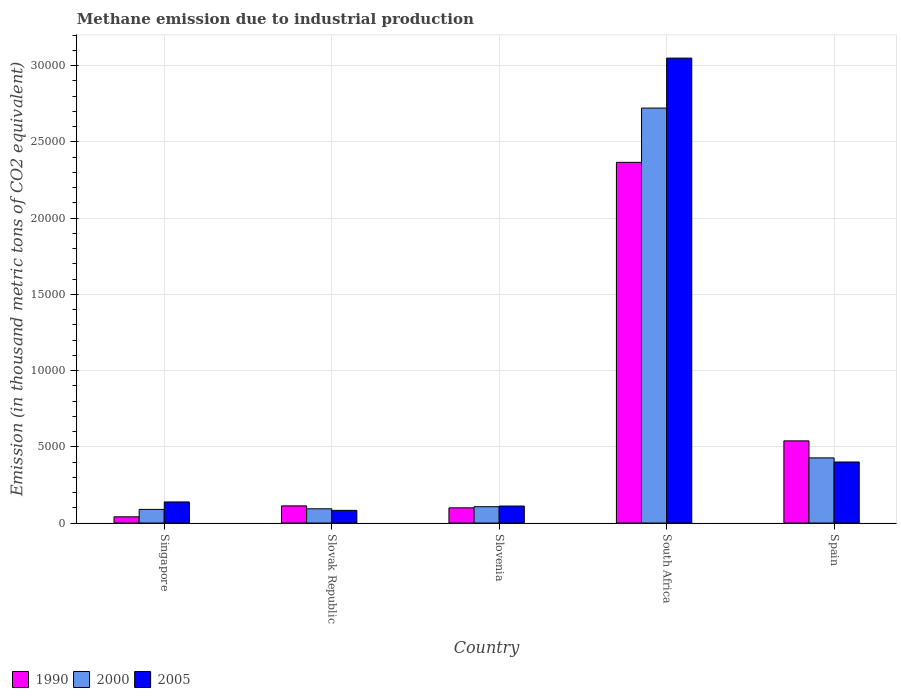How many different coloured bars are there?
Give a very brief answer. 3. How many groups of bars are there?
Offer a terse response. 5. How many bars are there on the 3rd tick from the left?
Provide a succinct answer. 3. How many bars are there on the 1st tick from the right?
Ensure brevity in your answer.  3. In how many cases, is the number of bars for a given country not equal to the number of legend labels?
Your answer should be very brief. 0. What is the amount of methane emitted in 2000 in Slovenia?
Provide a short and direct response. 1071.1. Across all countries, what is the maximum amount of methane emitted in 2005?
Offer a very short reply. 3.05e+04. Across all countries, what is the minimum amount of methane emitted in 2000?
Ensure brevity in your answer.  893.5. In which country was the amount of methane emitted in 1990 maximum?
Keep it short and to the point. South Africa. In which country was the amount of methane emitted in 2005 minimum?
Offer a very short reply. Slovak Republic. What is the total amount of methane emitted in 2005 in the graph?
Provide a short and direct response. 3.78e+04. What is the difference between the amount of methane emitted in 2000 in Slovak Republic and that in Slovenia?
Your answer should be compact. -137. What is the difference between the amount of methane emitted in 2000 in Slovenia and the amount of methane emitted in 2005 in Spain?
Provide a short and direct response. -2931.5. What is the average amount of methane emitted in 2005 per country?
Your answer should be compact. 7563.04. What is the difference between the amount of methane emitted of/in 2005 and amount of methane emitted of/in 2000 in Slovenia?
Your response must be concise. 43.3. What is the ratio of the amount of methane emitted in 2000 in Slovak Republic to that in Spain?
Offer a very short reply. 0.22. What is the difference between the highest and the second highest amount of methane emitted in 2000?
Offer a very short reply. 3199.9. What is the difference between the highest and the lowest amount of methane emitted in 2005?
Your response must be concise. 2.97e+04. What does the 1st bar from the left in Singapore represents?
Your response must be concise. 1990. Is it the case that in every country, the sum of the amount of methane emitted in 2005 and amount of methane emitted in 2000 is greater than the amount of methane emitted in 1990?
Provide a short and direct response. Yes. How many bars are there?
Provide a succinct answer. 15. How many countries are there in the graph?
Give a very brief answer. 5. Are the values on the major ticks of Y-axis written in scientific E-notation?
Offer a terse response. No. Does the graph contain grids?
Offer a very short reply. Yes. Where does the legend appear in the graph?
Your answer should be compact. Bottom left. How many legend labels are there?
Your answer should be compact. 3. How are the legend labels stacked?
Your answer should be very brief. Horizontal. What is the title of the graph?
Provide a short and direct response. Methane emission due to industrial production. What is the label or title of the X-axis?
Provide a short and direct response. Country. What is the label or title of the Y-axis?
Keep it short and to the point. Emission (in thousand metric tons of CO2 equivalent). What is the Emission (in thousand metric tons of CO2 equivalent) in 1990 in Singapore?
Your answer should be very brief. 406.8. What is the Emission (in thousand metric tons of CO2 equivalent) in 2000 in Singapore?
Provide a short and direct response. 893.5. What is the Emission (in thousand metric tons of CO2 equivalent) of 2005 in Singapore?
Ensure brevity in your answer.  1383. What is the Emission (in thousand metric tons of CO2 equivalent) in 1990 in Slovak Republic?
Offer a terse response. 1125.1. What is the Emission (in thousand metric tons of CO2 equivalent) in 2000 in Slovak Republic?
Make the answer very short. 934.1. What is the Emission (in thousand metric tons of CO2 equivalent) of 2005 in Slovak Republic?
Your answer should be compact. 830.9. What is the Emission (in thousand metric tons of CO2 equivalent) of 1990 in Slovenia?
Give a very brief answer. 996.3. What is the Emission (in thousand metric tons of CO2 equivalent) in 2000 in Slovenia?
Make the answer very short. 1071.1. What is the Emission (in thousand metric tons of CO2 equivalent) of 2005 in Slovenia?
Provide a short and direct response. 1114.4. What is the Emission (in thousand metric tons of CO2 equivalent) in 1990 in South Africa?
Ensure brevity in your answer.  2.36e+04. What is the Emission (in thousand metric tons of CO2 equivalent) of 2000 in South Africa?
Make the answer very short. 2.72e+04. What is the Emission (in thousand metric tons of CO2 equivalent) in 2005 in South Africa?
Offer a terse response. 3.05e+04. What is the Emission (in thousand metric tons of CO2 equivalent) in 1990 in Spain?
Your answer should be compact. 5387.8. What is the Emission (in thousand metric tons of CO2 equivalent) of 2000 in Spain?
Ensure brevity in your answer.  4271. What is the Emission (in thousand metric tons of CO2 equivalent) in 2005 in Spain?
Keep it short and to the point. 4002.6. Across all countries, what is the maximum Emission (in thousand metric tons of CO2 equivalent) of 1990?
Ensure brevity in your answer.  2.36e+04. Across all countries, what is the maximum Emission (in thousand metric tons of CO2 equivalent) in 2000?
Provide a succinct answer. 2.72e+04. Across all countries, what is the maximum Emission (in thousand metric tons of CO2 equivalent) in 2005?
Provide a succinct answer. 3.05e+04. Across all countries, what is the minimum Emission (in thousand metric tons of CO2 equivalent) in 1990?
Give a very brief answer. 406.8. Across all countries, what is the minimum Emission (in thousand metric tons of CO2 equivalent) of 2000?
Ensure brevity in your answer.  893.5. Across all countries, what is the minimum Emission (in thousand metric tons of CO2 equivalent) in 2005?
Your response must be concise. 830.9. What is the total Emission (in thousand metric tons of CO2 equivalent) of 1990 in the graph?
Keep it short and to the point. 3.16e+04. What is the total Emission (in thousand metric tons of CO2 equivalent) of 2000 in the graph?
Offer a terse response. 3.44e+04. What is the total Emission (in thousand metric tons of CO2 equivalent) in 2005 in the graph?
Provide a short and direct response. 3.78e+04. What is the difference between the Emission (in thousand metric tons of CO2 equivalent) in 1990 in Singapore and that in Slovak Republic?
Your response must be concise. -718.3. What is the difference between the Emission (in thousand metric tons of CO2 equivalent) in 2000 in Singapore and that in Slovak Republic?
Provide a short and direct response. -40.6. What is the difference between the Emission (in thousand metric tons of CO2 equivalent) of 2005 in Singapore and that in Slovak Republic?
Ensure brevity in your answer.  552.1. What is the difference between the Emission (in thousand metric tons of CO2 equivalent) of 1990 in Singapore and that in Slovenia?
Give a very brief answer. -589.5. What is the difference between the Emission (in thousand metric tons of CO2 equivalent) of 2000 in Singapore and that in Slovenia?
Provide a succinct answer. -177.6. What is the difference between the Emission (in thousand metric tons of CO2 equivalent) of 2005 in Singapore and that in Slovenia?
Make the answer very short. 268.6. What is the difference between the Emission (in thousand metric tons of CO2 equivalent) of 1990 in Singapore and that in South Africa?
Make the answer very short. -2.32e+04. What is the difference between the Emission (in thousand metric tons of CO2 equivalent) of 2000 in Singapore and that in South Africa?
Give a very brief answer. -2.63e+04. What is the difference between the Emission (in thousand metric tons of CO2 equivalent) of 2005 in Singapore and that in South Africa?
Offer a very short reply. -2.91e+04. What is the difference between the Emission (in thousand metric tons of CO2 equivalent) of 1990 in Singapore and that in Spain?
Keep it short and to the point. -4981. What is the difference between the Emission (in thousand metric tons of CO2 equivalent) of 2000 in Singapore and that in Spain?
Make the answer very short. -3377.5. What is the difference between the Emission (in thousand metric tons of CO2 equivalent) in 2005 in Singapore and that in Spain?
Give a very brief answer. -2619.6. What is the difference between the Emission (in thousand metric tons of CO2 equivalent) in 1990 in Slovak Republic and that in Slovenia?
Your answer should be very brief. 128.8. What is the difference between the Emission (in thousand metric tons of CO2 equivalent) of 2000 in Slovak Republic and that in Slovenia?
Give a very brief answer. -137. What is the difference between the Emission (in thousand metric tons of CO2 equivalent) of 2005 in Slovak Republic and that in Slovenia?
Offer a terse response. -283.5. What is the difference between the Emission (in thousand metric tons of CO2 equivalent) of 1990 in Slovak Republic and that in South Africa?
Offer a terse response. -2.25e+04. What is the difference between the Emission (in thousand metric tons of CO2 equivalent) in 2000 in Slovak Republic and that in South Africa?
Offer a terse response. -2.63e+04. What is the difference between the Emission (in thousand metric tons of CO2 equivalent) of 2005 in Slovak Republic and that in South Africa?
Provide a succinct answer. -2.97e+04. What is the difference between the Emission (in thousand metric tons of CO2 equivalent) of 1990 in Slovak Republic and that in Spain?
Ensure brevity in your answer.  -4262.7. What is the difference between the Emission (in thousand metric tons of CO2 equivalent) of 2000 in Slovak Republic and that in Spain?
Your answer should be very brief. -3336.9. What is the difference between the Emission (in thousand metric tons of CO2 equivalent) of 2005 in Slovak Republic and that in Spain?
Offer a very short reply. -3171.7. What is the difference between the Emission (in thousand metric tons of CO2 equivalent) of 1990 in Slovenia and that in South Africa?
Give a very brief answer. -2.27e+04. What is the difference between the Emission (in thousand metric tons of CO2 equivalent) of 2000 in Slovenia and that in South Africa?
Give a very brief answer. -2.61e+04. What is the difference between the Emission (in thousand metric tons of CO2 equivalent) of 2005 in Slovenia and that in South Africa?
Your response must be concise. -2.94e+04. What is the difference between the Emission (in thousand metric tons of CO2 equivalent) in 1990 in Slovenia and that in Spain?
Ensure brevity in your answer.  -4391.5. What is the difference between the Emission (in thousand metric tons of CO2 equivalent) of 2000 in Slovenia and that in Spain?
Provide a succinct answer. -3199.9. What is the difference between the Emission (in thousand metric tons of CO2 equivalent) of 2005 in Slovenia and that in Spain?
Keep it short and to the point. -2888.2. What is the difference between the Emission (in thousand metric tons of CO2 equivalent) in 1990 in South Africa and that in Spain?
Give a very brief answer. 1.83e+04. What is the difference between the Emission (in thousand metric tons of CO2 equivalent) in 2000 in South Africa and that in Spain?
Ensure brevity in your answer.  2.29e+04. What is the difference between the Emission (in thousand metric tons of CO2 equivalent) of 2005 in South Africa and that in Spain?
Offer a terse response. 2.65e+04. What is the difference between the Emission (in thousand metric tons of CO2 equivalent) of 1990 in Singapore and the Emission (in thousand metric tons of CO2 equivalent) of 2000 in Slovak Republic?
Offer a terse response. -527.3. What is the difference between the Emission (in thousand metric tons of CO2 equivalent) in 1990 in Singapore and the Emission (in thousand metric tons of CO2 equivalent) in 2005 in Slovak Republic?
Give a very brief answer. -424.1. What is the difference between the Emission (in thousand metric tons of CO2 equivalent) of 2000 in Singapore and the Emission (in thousand metric tons of CO2 equivalent) of 2005 in Slovak Republic?
Your answer should be very brief. 62.6. What is the difference between the Emission (in thousand metric tons of CO2 equivalent) in 1990 in Singapore and the Emission (in thousand metric tons of CO2 equivalent) in 2000 in Slovenia?
Provide a succinct answer. -664.3. What is the difference between the Emission (in thousand metric tons of CO2 equivalent) of 1990 in Singapore and the Emission (in thousand metric tons of CO2 equivalent) of 2005 in Slovenia?
Make the answer very short. -707.6. What is the difference between the Emission (in thousand metric tons of CO2 equivalent) in 2000 in Singapore and the Emission (in thousand metric tons of CO2 equivalent) in 2005 in Slovenia?
Your response must be concise. -220.9. What is the difference between the Emission (in thousand metric tons of CO2 equivalent) of 1990 in Singapore and the Emission (in thousand metric tons of CO2 equivalent) of 2000 in South Africa?
Provide a short and direct response. -2.68e+04. What is the difference between the Emission (in thousand metric tons of CO2 equivalent) in 1990 in Singapore and the Emission (in thousand metric tons of CO2 equivalent) in 2005 in South Africa?
Your answer should be compact. -3.01e+04. What is the difference between the Emission (in thousand metric tons of CO2 equivalent) of 2000 in Singapore and the Emission (in thousand metric tons of CO2 equivalent) of 2005 in South Africa?
Provide a short and direct response. -2.96e+04. What is the difference between the Emission (in thousand metric tons of CO2 equivalent) in 1990 in Singapore and the Emission (in thousand metric tons of CO2 equivalent) in 2000 in Spain?
Give a very brief answer. -3864.2. What is the difference between the Emission (in thousand metric tons of CO2 equivalent) in 1990 in Singapore and the Emission (in thousand metric tons of CO2 equivalent) in 2005 in Spain?
Your answer should be compact. -3595.8. What is the difference between the Emission (in thousand metric tons of CO2 equivalent) in 2000 in Singapore and the Emission (in thousand metric tons of CO2 equivalent) in 2005 in Spain?
Ensure brevity in your answer.  -3109.1. What is the difference between the Emission (in thousand metric tons of CO2 equivalent) in 1990 in Slovak Republic and the Emission (in thousand metric tons of CO2 equivalent) in 2000 in Slovenia?
Your answer should be very brief. 54. What is the difference between the Emission (in thousand metric tons of CO2 equivalent) in 1990 in Slovak Republic and the Emission (in thousand metric tons of CO2 equivalent) in 2005 in Slovenia?
Make the answer very short. 10.7. What is the difference between the Emission (in thousand metric tons of CO2 equivalent) in 2000 in Slovak Republic and the Emission (in thousand metric tons of CO2 equivalent) in 2005 in Slovenia?
Keep it short and to the point. -180.3. What is the difference between the Emission (in thousand metric tons of CO2 equivalent) of 1990 in Slovak Republic and the Emission (in thousand metric tons of CO2 equivalent) of 2000 in South Africa?
Offer a terse response. -2.61e+04. What is the difference between the Emission (in thousand metric tons of CO2 equivalent) of 1990 in Slovak Republic and the Emission (in thousand metric tons of CO2 equivalent) of 2005 in South Africa?
Your answer should be very brief. -2.94e+04. What is the difference between the Emission (in thousand metric tons of CO2 equivalent) of 2000 in Slovak Republic and the Emission (in thousand metric tons of CO2 equivalent) of 2005 in South Africa?
Provide a succinct answer. -2.96e+04. What is the difference between the Emission (in thousand metric tons of CO2 equivalent) of 1990 in Slovak Republic and the Emission (in thousand metric tons of CO2 equivalent) of 2000 in Spain?
Provide a short and direct response. -3145.9. What is the difference between the Emission (in thousand metric tons of CO2 equivalent) of 1990 in Slovak Republic and the Emission (in thousand metric tons of CO2 equivalent) of 2005 in Spain?
Provide a succinct answer. -2877.5. What is the difference between the Emission (in thousand metric tons of CO2 equivalent) in 2000 in Slovak Republic and the Emission (in thousand metric tons of CO2 equivalent) in 2005 in Spain?
Make the answer very short. -3068.5. What is the difference between the Emission (in thousand metric tons of CO2 equivalent) of 1990 in Slovenia and the Emission (in thousand metric tons of CO2 equivalent) of 2000 in South Africa?
Ensure brevity in your answer.  -2.62e+04. What is the difference between the Emission (in thousand metric tons of CO2 equivalent) in 1990 in Slovenia and the Emission (in thousand metric tons of CO2 equivalent) in 2005 in South Africa?
Your answer should be compact. -2.95e+04. What is the difference between the Emission (in thousand metric tons of CO2 equivalent) in 2000 in Slovenia and the Emission (in thousand metric tons of CO2 equivalent) in 2005 in South Africa?
Make the answer very short. -2.94e+04. What is the difference between the Emission (in thousand metric tons of CO2 equivalent) in 1990 in Slovenia and the Emission (in thousand metric tons of CO2 equivalent) in 2000 in Spain?
Your response must be concise. -3274.7. What is the difference between the Emission (in thousand metric tons of CO2 equivalent) of 1990 in Slovenia and the Emission (in thousand metric tons of CO2 equivalent) of 2005 in Spain?
Offer a terse response. -3006.3. What is the difference between the Emission (in thousand metric tons of CO2 equivalent) in 2000 in Slovenia and the Emission (in thousand metric tons of CO2 equivalent) in 2005 in Spain?
Offer a very short reply. -2931.5. What is the difference between the Emission (in thousand metric tons of CO2 equivalent) in 1990 in South Africa and the Emission (in thousand metric tons of CO2 equivalent) in 2000 in Spain?
Your answer should be compact. 1.94e+04. What is the difference between the Emission (in thousand metric tons of CO2 equivalent) in 1990 in South Africa and the Emission (in thousand metric tons of CO2 equivalent) in 2005 in Spain?
Your response must be concise. 1.96e+04. What is the difference between the Emission (in thousand metric tons of CO2 equivalent) of 2000 in South Africa and the Emission (in thousand metric tons of CO2 equivalent) of 2005 in Spain?
Ensure brevity in your answer.  2.32e+04. What is the average Emission (in thousand metric tons of CO2 equivalent) in 1990 per country?
Your answer should be very brief. 6313.1. What is the average Emission (in thousand metric tons of CO2 equivalent) in 2000 per country?
Offer a very short reply. 6875.5. What is the average Emission (in thousand metric tons of CO2 equivalent) of 2005 per country?
Your answer should be compact. 7563.04. What is the difference between the Emission (in thousand metric tons of CO2 equivalent) of 1990 and Emission (in thousand metric tons of CO2 equivalent) of 2000 in Singapore?
Ensure brevity in your answer.  -486.7. What is the difference between the Emission (in thousand metric tons of CO2 equivalent) in 1990 and Emission (in thousand metric tons of CO2 equivalent) in 2005 in Singapore?
Give a very brief answer. -976.2. What is the difference between the Emission (in thousand metric tons of CO2 equivalent) of 2000 and Emission (in thousand metric tons of CO2 equivalent) of 2005 in Singapore?
Make the answer very short. -489.5. What is the difference between the Emission (in thousand metric tons of CO2 equivalent) of 1990 and Emission (in thousand metric tons of CO2 equivalent) of 2000 in Slovak Republic?
Your answer should be compact. 191. What is the difference between the Emission (in thousand metric tons of CO2 equivalent) of 1990 and Emission (in thousand metric tons of CO2 equivalent) of 2005 in Slovak Republic?
Ensure brevity in your answer.  294.2. What is the difference between the Emission (in thousand metric tons of CO2 equivalent) of 2000 and Emission (in thousand metric tons of CO2 equivalent) of 2005 in Slovak Republic?
Keep it short and to the point. 103.2. What is the difference between the Emission (in thousand metric tons of CO2 equivalent) of 1990 and Emission (in thousand metric tons of CO2 equivalent) of 2000 in Slovenia?
Keep it short and to the point. -74.8. What is the difference between the Emission (in thousand metric tons of CO2 equivalent) of 1990 and Emission (in thousand metric tons of CO2 equivalent) of 2005 in Slovenia?
Your answer should be very brief. -118.1. What is the difference between the Emission (in thousand metric tons of CO2 equivalent) in 2000 and Emission (in thousand metric tons of CO2 equivalent) in 2005 in Slovenia?
Your answer should be very brief. -43.3. What is the difference between the Emission (in thousand metric tons of CO2 equivalent) of 1990 and Emission (in thousand metric tons of CO2 equivalent) of 2000 in South Africa?
Ensure brevity in your answer.  -3558.3. What is the difference between the Emission (in thousand metric tons of CO2 equivalent) in 1990 and Emission (in thousand metric tons of CO2 equivalent) in 2005 in South Africa?
Provide a succinct answer. -6834.8. What is the difference between the Emission (in thousand metric tons of CO2 equivalent) in 2000 and Emission (in thousand metric tons of CO2 equivalent) in 2005 in South Africa?
Provide a short and direct response. -3276.5. What is the difference between the Emission (in thousand metric tons of CO2 equivalent) in 1990 and Emission (in thousand metric tons of CO2 equivalent) in 2000 in Spain?
Your response must be concise. 1116.8. What is the difference between the Emission (in thousand metric tons of CO2 equivalent) in 1990 and Emission (in thousand metric tons of CO2 equivalent) in 2005 in Spain?
Your response must be concise. 1385.2. What is the difference between the Emission (in thousand metric tons of CO2 equivalent) in 2000 and Emission (in thousand metric tons of CO2 equivalent) in 2005 in Spain?
Provide a succinct answer. 268.4. What is the ratio of the Emission (in thousand metric tons of CO2 equivalent) of 1990 in Singapore to that in Slovak Republic?
Your response must be concise. 0.36. What is the ratio of the Emission (in thousand metric tons of CO2 equivalent) in 2000 in Singapore to that in Slovak Republic?
Your response must be concise. 0.96. What is the ratio of the Emission (in thousand metric tons of CO2 equivalent) of 2005 in Singapore to that in Slovak Republic?
Your answer should be very brief. 1.66. What is the ratio of the Emission (in thousand metric tons of CO2 equivalent) in 1990 in Singapore to that in Slovenia?
Your answer should be very brief. 0.41. What is the ratio of the Emission (in thousand metric tons of CO2 equivalent) of 2000 in Singapore to that in Slovenia?
Ensure brevity in your answer.  0.83. What is the ratio of the Emission (in thousand metric tons of CO2 equivalent) in 2005 in Singapore to that in Slovenia?
Ensure brevity in your answer.  1.24. What is the ratio of the Emission (in thousand metric tons of CO2 equivalent) of 1990 in Singapore to that in South Africa?
Ensure brevity in your answer.  0.02. What is the ratio of the Emission (in thousand metric tons of CO2 equivalent) of 2000 in Singapore to that in South Africa?
Make the answer very short. 0.03. What is the ratio of the Emission (in thousand metric tons of CO2 equivalent) of 2005 in Singapore to that in South Africa?
Your answer should be very brief. 0.05. What is the ratio of the Emission (in thousand metric tons of CO2 equivalent) in 1990 in Singapore to that in Spain?
Provide a succinct answer. 0.08. What is the ratio of the Emission (in thousand metric tons of CO2 equivalent) of 2000 in Singapore to that in Spain?
Your answer should be very brief. 0.21. What is the ratio of the Emission (in thousand metric tons of CO2 equivalent) in 2005 in Singapore to that in Spain?
Offer a very short reply. 0.35. What is the ratio of the Emission (in thousand metric tons of CO2 equivalent) of 1990 in Slovak Republic to that in Slovenia?
Offer a terse response. 1.13. What is the ratio of the Emission (in thousand metric tons of CO2 equivalent) in 2000 in Slovak Republic to that in Slovenia?
Give a very brief answer. 0.87. What is the ratio of the Emission (in thousand metric tons of CO2 equivalent) in 2005 in Slovak Republic to that in Slovenia?
Make the answer very short. 0.75. What is the ratio of the Emission (in thousand metric tons of CO2 equivalent) in 1990 in Slovak Republic to that in South Africa?
Make the answer very short. 0.05. What is the ratio of the Emission (in thousand metric tons of CO2 equivalent) of 2000 in Slovak Republic to that in South Africa?
Offer a terse response. 0.03. What is the ratio of the Emission (in thousand metric tons of CO2 equivalent) of 2005 in Slovak Republic to that in South Africa?
Keep it short and to the point. 0.03. What is the ratio of the Emission (in thousand metric tons of CO2 equivalent) in 1990 in Slovak Republic to that in Spain?
Give a very brief answer. 0.21. What is the ratio of the Emission (in thousand metric tons of CO2 equivalent) of 2000 in Slovak Republic to that in Spain?
Your answer should be compact. 0.22. What is the ratio of the Emission (in thousand metric tons of CO2 equivalent) in 2005 in Slovak Republic to that in Spain?
Your response must be concise. 0.21. What is the ratio of the Emission (in thousand metric tons of CO2 equivalent) of 1990 in Slovenia to that in South Africa?
Offer a terse response. 0.04. What is the ratio of the Emission (in thousand metric tons of CO2 equivalent) of 2000 in Slovenia to that in South Africa?
Your answer should be compact. 0.04. What is the ratio of the Emission (in thousand metric tons of CO2 equivalent) in 2005 in Slovenia to that in South Africa?
Your answer should be very brief. 0.04. What is the ratio of the Emission (in thousand metric tons of CO2 equivalent) of 1990 in Slovenia to that in Spain?
Make the answer very short. 0.18. What is the ratio of the Emission (in thousand metric tons of CO2 equivalent) of 2000 in Slovenia to that in Spain?
Ensure brevity in your answer.  0.25. What is the ratio of the Emission (in thousand metric tons of CO2 equivalent) of 2005 in Slovenia to that in Spain?
Provide a succinct answer. 0.28. What is the ratio of the Emission (in thousand metric tons of CO2 equivalent) of 1990 in South Africa to that in Spain?
Ensure brevity in your answer.  4.39. What is the ratio of the Emission (in thousand metric tons of CO2 equivalent) in 2000 in South Africa to that in Spain?
Your answer should be very brief. 6.37. What is the ratio of the Emission (in thousand metric tons of CO2 equivalent) of 2005 in South Africa to that in Spain?
Offer a terse response. 7.62. What is the difference between the highest and the second highest Emission (in thousand metric tons of CO2 equivalent) of 1990?
Keep it short and to the point. 1.83e+04. What is the difference between the highest and the second highest Emission (in thousand metric tons of CO2 equivalent) of 2000?
Give a very brief answer. 2.29e+04. What is the difference between the highest and the second highest Emission (in thousand metric tons of CO2 equivalent) in 2005?
Offer a terse response. 2.65e+04. What is the difference between the highest and the lowest Emission (in thousand metric tons of CO2 equivalent) in 1990?
Your answer should be very brief. 2.32e+04. What is the difference between the highest and the lowest Emission (in thousand metric tons of CO2 equivalent) of 2000?
Keep it short and to the point. 2.63e+04. What is the difference between the highest and the lowest Emission (in thousand metric tons of CO2 equivalent) of 2005?
Keep it short and to the point. 2.97e+04. 